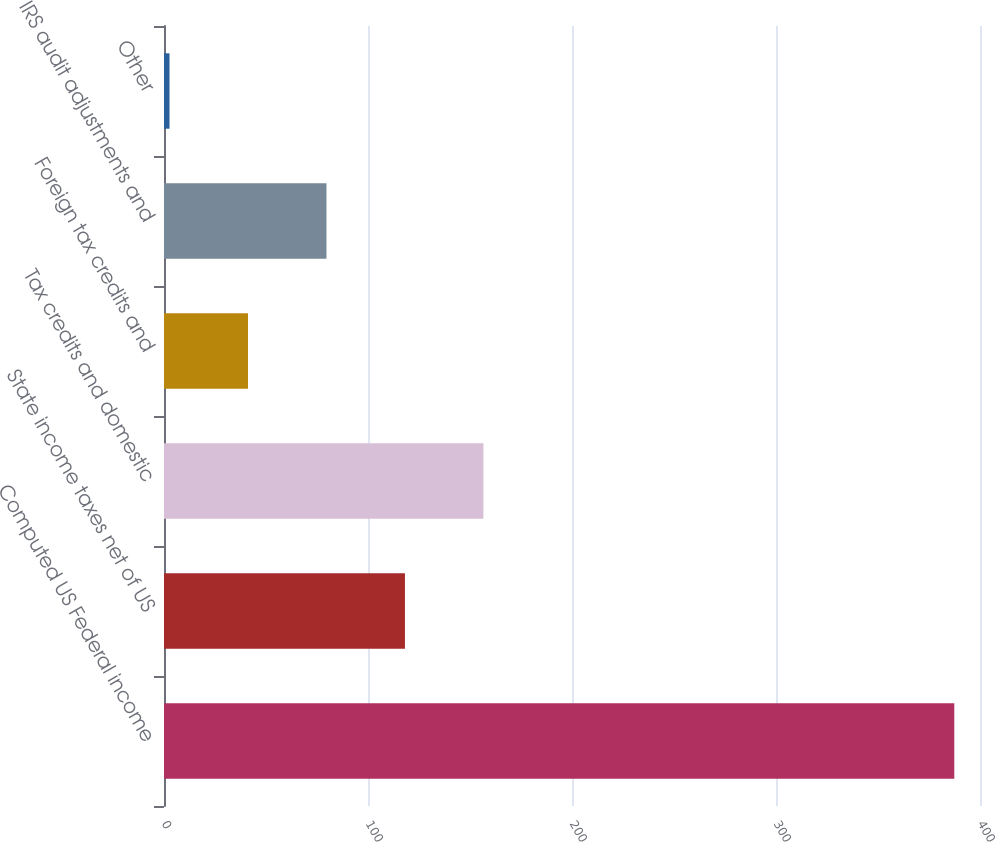Convert chart. <chart><loc_0><loc_0><loc_500><loc_500><bar_chart><fcel>Computed US Federal income<fcel>State income taxes net of US<fcel>Tax credits and domestic<fcel>Foreign tax credits and<fcel>IRS audit adjustments and<fcel>Other<nl><fcel>387.4<fcel>118.11<fcel>156.58<fcel>41.17<fcel>79.64<fcel>2.7<nl></chart> 